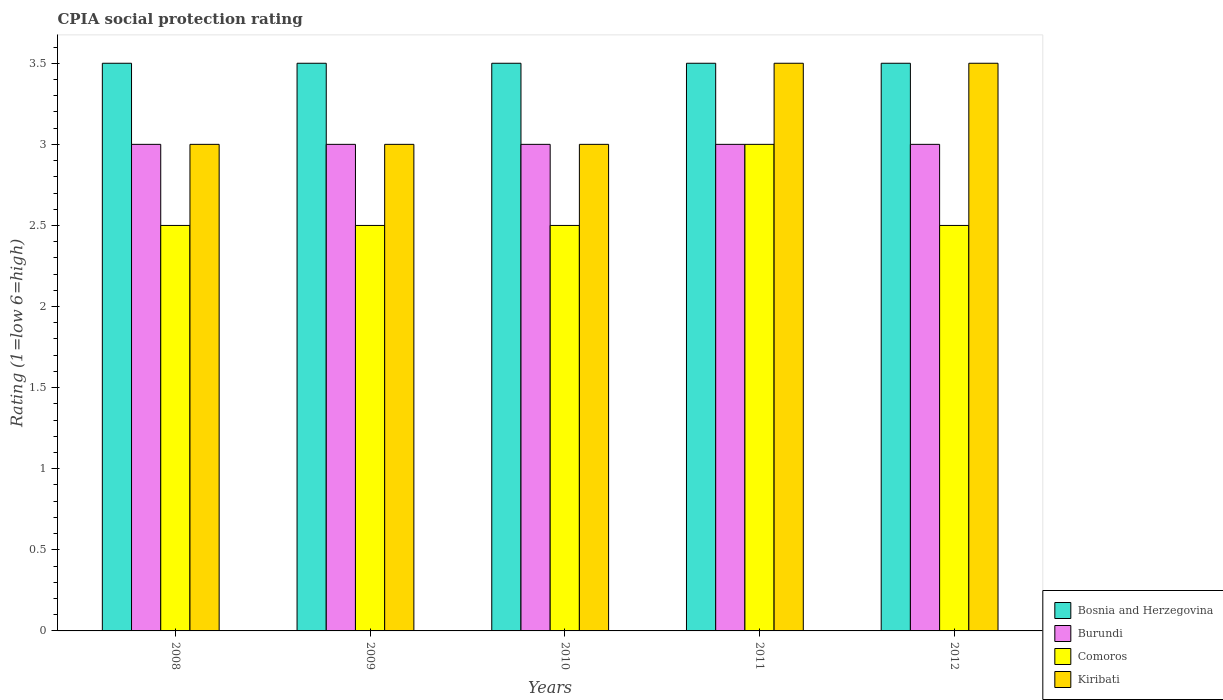How many groups of bars are there?
Ensure brevity in your answer.  5. Are the number of bars per tick equal to the number of legend labels?
Offer a terse response. Yes. How many bars are there on the 1st tick from the right?
Your answer should be compact. 4. Across all years, what is the maximum CPIA rating in Bosnia and Herzegovina?
Your answer should be compact. 3.5. Across all years, what is the minimum CPIA rating in Burundi?
Provide a succinct answer. 3. In which year was the CPIA rating in Burundi maximum?
Provide a short and direct response. 2008. What is the total CPIA rating in Burundi in the graph?
Make the answer very short. 15. What is the difference between the CPIA rating in Bosnia and Herzegovina in 2008 and that in 2010?
Provide a succinct answer. 0. What is the average CPIA rating in Bosnia and Herzegovina per year?
Offer a terse response. 3.5. What is the ratio of the CPIA rating in Comoros in 2010 to that in 2011?
Your answer should be very brief. 0.83. Is the difference between the CPIA rating in Comoros in 2010 and 2011 greater than the difference between the CPIA rating in Kiribati in 2010 and 2011?
Provide a succinct answer. No. In how many years, is the CPIA rating in Burundi greater than the average CPIA rating in Burundi taken over all years?
Ensure brevity in your answer.  0. Is the sum of the CPIA rating in Burundi in 2008 and 2009 greater than the maximum CPIA rating in Comoros across all years?
Provide a short and direct response. Yes. Is it the case that in every year, the sum of the CPIA rating in Comoros and CPIA rating in Bosnia and Herzegovina is greater than the sum of CPIA rating in Burundi and CPIA rating in Kiribati?
Offer a terse response. No. What does the 4th bar from the left in 2010 represents?
Keep it short and to the point. Kiribati. What does the 4th bar from the right in 2010 represents?
Make the answer very short. Bosnia and Herzegovina. How many years are there in the graph?
Your answer should be compact. 5. Does the graph contain any zero values?
Make the answer very short. No. Where does the legend appear in the graph?
Provide a succinct answer. Bottom right. What is the title of the graph?
Your response must be concise. CPIA social protection rating. What is the label or title of the X-axis?
Offer a terse response. Years. What is the label or title of the Y-axis?
Your answer should be very brief. Rating (1=low 6=high). What is the Rating (1=low 6=high) in Burundi in 2008?
Your response must be concise. 3. What is the Rating (1=low 6=high) of Comoros in 2008?
Your response must be concise. 2.5. What is the Rating (1=low 6=high) in Burundi in 2009?
Make the answer very short. 3. What is the Rating (1=low 6=high) of Comoros in 2009?
Your answer should be compact. 2.5. What is the Rating (1=low 6=high) in Burundi in 2010?
Give a very brief answer. 3. What is the Rating (1=low 6=high) in Comoros in 2010?
Provide a short and direct response. 2.5. What is the Rating (1=low 6=high) of Burundi in 2011?
Ensure brevity in your answer.  3. What is the Rating (1=low 6=high) of Comoros in 2011?
Your answer should be very brief. 3. What is the Rating (1=low 6=high) of Burundi in 2012?
Your answer should be compact. 3. What is the Rating (1=low 6=high) in Kiribati in 2012?
Make the answer very short. 3.5. Across all years, what is the maximum Rating (1=low 6=high) in Burundi?
Provide a short and direct response. 3. Across all years, what is the maximum Rating (1=low 6=high) of Comoros?
Provide a succinct answer. 3. Across all years, what is the maximum Rating (1=low 6=high) of Kiribati?
Provide a succinct answer. 3.5. Across all years, what is the minimum Rating (1=low 6=high) of Bosnia and Herzegovina?
Give a very brief answer. 3.5. Across all years, what is the minimum Rating (1=low 6=high) in Burundi?
Ensure brevity in your answer.  3. Across all years, what is the minimum Rating (1=low 6=high) of Kiribati?
Keep it short and to the point. 3. What is the total Rating (1=low 6=high) of Bosnia and Herzegovina in the graph?
Your answer should be compact. 17.5. What is the total Rating (1=low 6=high) of Comoros in the graph?
Make the answer very short. 13. What is the difference between the Rating (1=low 6=high) of Burundi in 2008 and that in 2009?
Make the answer very short. 0. What is the difference between the Rating (1=low 6=high) in Kiribati in 2008 and that in 2009?
Make the answer very short. 0. What is the difference between the Rating (1=low 6=high) of Kiribati in 2008 and that in 2010?
Your response must be concise. 0. What is the difference between the Rating (1=low 6=high) in Bosnia and Herzegovina in 2008 and that in 2011?
Your answer should be compact. 0. What is the difference between the Rating (1=low 6=high) of Bosnia and Herzegovina in 2008 and that in 2012?
Provide a succinct answer. 0. What is the difference between the Rating (1=low 6=high) in Burundi in 2008 and that in 2012?
Ensure brevity in your answer.  0. What is the difference between the Rating (1=low 6=high) of Comoros in 2008 and that in 2012?
Provide a short and direct response. 0. What is the difference between the Rating (1=low 6=high) of Bosnia and Herzegovina in 2009 and that in 2011?
Provide a succinct answer. 0. What is the difference between the Rating (1=low 6=high) in Comoros in 2009 and that in 2011?
Offer a very short reply. -0.5. What is the difference between the Rating (1=low 6=high) of Kiribati in 2009 and that in 2011?
Ensure brevity in your answer.  -0.5. What is the difference between the Rating (1=low 6=high) in Bosnia and Herzegovina in 2009 and that in 2012?
Your response must be concise. 0. What is the difference between the Rating (1=low 6=high) in Comoros in 2009 and that in 2012?
Offer a very short reply. 0. What is the difference between the Rating (1=low 6=high) of Bosnia and Herzegovina in 2010 and that in 2011?
Offer a very short reply. 0. What is the difference between the Rating (1=low 6=high) of Kiribati in 2010 and that in 2011?
Offer a very short reply. -0.5. What is the difference between the Rating (1=low 6=high) in Comoros in 2010 and that in 2012?
Make the answer very short. 0. What is the difference between the Rating (1=low 6=high) in Bosnia and Herzegovina in 2011 and that in 2012?
Your answer should be very brief. 0. What is the difference between the Rating (1=low 6=high) of Comoros in 2011 and that in 2012?
Provide a succinct answer. 0.5. What is the difference between the Rating (1=low 6=high) of Kiribati in 2011 and that in 2012?
Your answer should be very brief. 0. What is the difference between the Rating (1=low 6=high) in Burundi in 2008 and the Rating (1=low 6=high) in Comoros in 2009?
Ensure brevity in your answer.  0.5. What is the difference between the Rating (1=low 6=high) in Bosnia and Herzegovina in 2008 and the Rating (1=low 6=high) in Burundi in 2010?
Ensure brevity in your answer.  0.5. What is the difference between the Rating (1=low 6=high) of Bosnia and Herzegovina in 2008 and the Rating (1=low 6=high) of Comoros in 2010?
Give a very brief answer. 1. What is the difference between the Rating (1=low 6=high) of Burundi in 2008 and the Rating (1=low 6=high) of Comoros in 2010?
Offer a terse response. 0.5. What is the difference between the Rating (1=low 6=high) of Burundi in 2008 and the Rating (1=low 6=high) of Kiribati in 2010?
Offer a very short reply. 0. What is the difference between the Rating (1=low 6=high) of Bosnia and Herzegovina in 2008 and the Rating (1=low 6=high) of Burundi in 2011?
Your response must be concise. 0.5. What is the difference between the Rating (1=low 6=high) in Bosnia and Herzegovina in 2008 and the Rating (1=low 6=high) in Kiribati in 2011?
Make the answer very short. 0. What is the difference between the Rating (1=low 6=high) in Burundi in 2008 and the Rating (1=low 6=high) in Comoros in 2011?
Your answer should be very brief. 0. What is the difference between the Rating (1=low 6=high) of Burundi in 2008 and the Rating (1=low 6=high) of Kiribati in 2011?
Your answer should be very brief. -0.5. What is the difference between the Rating (1=low 6=high) of Bosnia and Herzegovina in 2008 and the Rating (1=low 6=high) of Burundi in 2012?
Your answer should be compact. 0.5. What is the difference between the Rating (1=low 6=high) in Bosnia and Herzegovina in 2008 and the Rating (1=low 6=high) in Comoros in 2012?
Offer a terse response. 1. What is the difference between the Rating (1=low 6=high) in Bosnia and Herzegovina in 2008 and the Rating (1=low 6=high) in Kiribati in 2012?
Your response must be concise. 0. What is the difference between the Rating (1=low 6=high) of Burundi in 2008 and the Rating (1=low 6=high) of Comoros in 2012?
Your response must be concise. 0.5. What is the difference between the Rating (1=low 6=high) in Burundi in 2008 and the Rating (1=low 6=high) in Kiribati in 2012?
Your answer should be very brief. -0.5. What is the difference between the Rating (1=low 6=high) of Bosnia and Herzegovina in 2009 and the Rating (1=low 6=high) of Burundi in 2010?
Make the answer very short. 0.5. What is the difference between the Rating (1=low 6=high) of Bosnia and Herzegovina in 2009 and the Rating (1=low 6=high) of Comoros in 2010?
Offer a terse response. 1. What is the difference between the Rating (1=low 6=high) of Bosnia and Herzegovina in 2009 and the Rating (1=low 6=high) of Kiribati in 2010?
Make the answer very short. 0.5. What is the difference between the Rating (1=low 6=high) in Burundi in 2009 and the Rating (1=low 6=high) in Comoros in 2010?
Make the answer very short. 0.5. What is the difference between the Rating (1=low 6=high) in Burundi in 2009 and the Rating (1=low 6=high) in Kiribati in 2010?
Your answer should be very brief. 0. What is the difference between the Rating (1=low 6=high) of Bosnia and Herzegovina in 2009 and the Rating (1=low 6=high) of Comoros in 2011?
Keep it short and to the point. 0.5. What is the difference between the Rating (1=low 6=high) of Burundi in 2009 and the Rating (1=low 6=high) of Comoros in 2011?
Provide a short and direct response. 0. What is the difference between the Rating (1=low 6=high) of Comoros in 2009 and the Rating (1=low 6=high) of Kiribati in 2011?
Your answer should be compact. -1. What is the difference between the Rating (1=low 6=high) in Bosnia and Herzegovina in 2009 and the Rating (1=low 6=high) in Burundi in 2012?
Provide a short and direct response. 0.5. What is the difference between the Rating (1=low 6=high) of Bosnia and Herzegovina in 2009 and the Rating (1=low 6=high) of Comoros in 2012?
Make the answer very short. 1. What is the difference between the Rating (1=low 6=high) in Bosnia and Herzegovina in 2009 and the Rating (1=low 6=high) in Kiribati in 2012?
Your response must be concise. 0. What is the difference between the Rating (1=low 6=high) of Comoros in 2009 and the Rating (1=low 6=high) of Kiribati in 2012?
Provide a succinct answer. -1. What is the difference between the Rating (1=low 6=high) of Bosnia and Herzegovina in 2010 and the Rating (1=low 6=high) of Comoros in 2011?
Your response must be concise. 0.5. What is the difference between the Rating (1=low 6=high) in Bosnia and Herzegovina in 2010 and the Rating (1=low 6=high) in Kiribati in 2011?
Make the answer very short. 0. What is the difference between the Rating (1=low 6=high) in Bosnia and Herzegovina in 2010 and the Rating (1=low 6=high) in Comoros in 2012?
Your answer should be very brief. 1. What is the difference between the Rating (1=low 6=high) of Bosnia and Herzegovina in 2010 and the Rating (1=low 6=high) of Kiribati in 2012?
Give a very brief answer. 0. What is the difference between the Rating (1=low 6=high) of Burundi in 2010 and the Rating (1=low 6=high) of Comoros in 2012?
Your answer should be very brief. 0.5. What is the difference between the Rating (1=low 6=high) in Bosnia and Herzegovina in 2011 and the Rating (1=low 6=high) in Comoros in 2012?
Ensure brevity in your answer.  1. What is the difference between the Rating (1=low 6=high) of Bosnia and Herzegovina in 2011 and the Rating (1=low 6=high) of Kiribati in 2012?
Offer a terse response. 0. What is the difference between the Rating (1=low 6=high) in Comoros in 2011 and the Rating (1=low 6=high) in Kiribati in 2012?
Make the answer very short. -0.5. What is the average Rating (1=low 6=high) in Kiribati per year?
Give a very brief answer. 3.2. In the year 2008, what is the difference between the Rating (1=low 6=high) in Bosnia and Herzegovina and Rating (1=low 6=high) in Burundi?
Your answer should be compact. 0.5. In the year 2008, what is the difference between the Rating (1=low 6=high) in Bosnia and Herzegovina and Rating (1=low 6=high) in Comoros?
Give a very brief answer. 1. In the year 2008, what is the difference between the Rating (1=low 6=high) in Burundi and Rating (1=low 6=high) in Kiribati?
Offer a very short reply. 0. In the year 2008, what is the difference between the Rating (1=low 6=high) in Comoros and Rating (1=low 6=high) in Kiribati?
Offer a terse response. -0.5. In the year 2009, what is the difference between the Rating (1=low 6=high) of Bosnia and Herzegovina and Rating (1=low 6=high) of Burundi?
Your answer should be very brief. 0.5. In the year 2009, what is the difference between the Rating (1=low 6=high) in Bosnia and Herzegovina and Rating (1=low 6=high) in Comoros?
Ensure brevity in your answer.  1. In the year 2009, what is the difference between the Rating (1=low 6=high) in Bosnia and Herzegovina and Rating (1=low 6=high) in Kiribati?
Provide a short and direct response. 0.5. In the year 2009, what is the difference between the Rating (1=low 6=high) in Comoros and Rating (1=low 6=high) in Kiribati?
Your answer should be compact. -0.5. In the year 2010, what is the difference between the Rating (1=low 6=high) in Bosnia and Herzegovina and Rating (1=low 6=high) in Burundi?
Offer a very short reply. 0.5. In the year 2010, what is the difference between the Rating (1=low 6=high) in Burundi and Rating (1=low 6=high) in Kiribati?
Provide a short and direct response. 0. In the year 2010, what is the difference between the Rating (1=low 6=high) in Comoros and Rating (1=low 6=high) in Kiribati?
Offer a very short reply. -0.5. In the year 2011, what is the difference between the Rating (1=low 6=high) of Bosnia and Herzegovina and Rating (1=low 6=high) of Burundi?
Your answer should be very brief. 0.5. In the year 2011, what is the difference between the Rating (1=low 6=high) in Bosnia and Herzegovina and Rating (1=low 6=high) in Kiribati?
Provide a short and direct response. 0. In the year 2011, what is the difference between the Rating (1=low 6=high) of Burundi and Rating (1=low 6=high) of Kiribati?
Your answer should be compact. -0.5. In the year 2012, what is the difference between the Rating (1=low 6=high) of Bosnia and Herzegovina and Rating (1=low 6=high) of Burundi?
Your answer should be compact. 0.5. In the year 2012, what is the difference between the Rating (1=low 6=high) in Bosnia and Herzegovina and Rating (1=low 6=high) in Kiribati?
Provide a succinct answer. 0. In the year 2012, what is the difference between the Rating (1=low 6=high) of Burundi and Rating (1=low 6=high) of Comoros?
Offer a terse response. 0.5. In the year 2012, what is the difference between the Rating (1=low 6=high) in Burundi and Rating (1=low 6=high) in Kiribati?
Keep it short and to the point. -0.5. In the year 2012, what is the difference between the Rating (1=low 6=high) of Comoros and Rating (1=low 6=high) of Kiribati?
Your answer should be very brief. -1. What is the ratio of the Rating (1=low 6=high) in Burundi in 2008 to that in 2009?
Ensure brevity in your answer.  1. What is the ratio of the Rating (1=low 6=high) of Comoros in 2008 to that in 2009?
Provide a short and direct response. 1. What is the ratio of the Rating (1=low 6=high) of Kiribati in 2008 to that in 2009?
Your answer should be compact. 1. What is the ratio of the Rating (1=low 6=high) in Bosnia and Herzegovina in 2008 to that in 2010?
Offer a very short reply. 1. What is the ratio of the Rating (1=low 6=high) in Burundi in 2008 to that in 2010?
Your response must be concise. 1. What is the ratio of the Rating (1=low 6=high) of Comoros in 2008 to that in 2010?
Your answer should be very brief. 1. What is the ratio of the Rating (1=low 6=high) in Bosnia and Herzegovina in 2008 to that in 2011?
Give a very brief answer. 1. What is the ratio of the Rating (1=low 6=high) in Comoros in 2008 to that in 2011?
Your answer should be compact. 0.83. What is the ratio of the Rating (1=low 6=high) in Kiribati in 2008 to that in 2011?
Offer a terse response. 0.86. What is the ratio of the Rating (1=low 6=high) in Comoros in 2008 to that in 2012?
Provide a succinct answer. 1. What is the ratio of the Rating (1=low 6=high) in Kiribati in 2008 to that in 2012?
Keep it short and to the point. 0.86. What is the ratio of the Rating (1=low 6=high) of Burundi in 2009 to that in 2010?
Your response must be concise. 1. What is the ratio of the Rating (1=low 6=high) in Bosnia and Herzegovina in 2009 to that in 2011?
Your answer should be very brief. 1. What is the ratio of the Rating (1=low 6=high) in Comoros in 2009 to that in 2011?
Make the answer very short. 0.83. What is the ratio of the Rating (1=low 6=high) of Kiribati in 2009 to that in 2012?
Ensure brevity in your answer.  0.86. What is the ratio of the Rating (1=low 6=high) in Bosnia and Herzegovina in 2010 to that in 2011?
Provide a short and direct response. 1. What is the ratio of the Rating (1=low 6=high) of Burundi in 2010 to that in 2011?
Keep it short and to the point. 1. What is the ratio of the Rating (1=low 6=high) in Kiribati in 2010 to that in 2011?
Offer a very short reply. 0.86. What is the ratio of the Rating (1=low 6=high) of Bosnia and Herzegovina in 2010 to that in 2012?
Offer a terse response. 1. What is the ratio of the Rating (1=low 6=high) of Burundi in 2010 to that in 2012?
Offer a terse response. 1. What is the ratio of the Rating (1=low 6=high) of Comoros in 2010 to that in 2012?
Offer a very short reply. 1. What is the ratio of the Rating (1=low 6=high) in Kiribati in 2010 to that in 2012?
Provide a short and direct response. 0.86. What is the ratio of the Rating (1=low 6=high) of Bosnia and Herzegovina in 2011 to that in 2012?
Your answer should be compact. 1. What is the ratio of the Rating (1=low 6=high) in Burundi in 2011 to that in 2012?
Your response must be concise. 1. What is the ratio of the Rating (1=low 6=high) of Comoros in 2011 to that in 2012?
Keep it short and to the point. 1.2. What is the ratio of the Rating (1=low 6=high) of Kiribati in 2011 to that in 2012?
Offer a very short reply. 1. What is the difference between the highest and the second highest Rating (1=low 6=high) in Bosnia and Herzegovina?
Offer a very short reply. 0. What is the difference between the highest and the second highest Rating (1=low 6=high) of Kiribati?
Your answer should be compact. 0. What is the difference between the highest and the lowest Rating (1=low 6=high) of Bosnia and Herzegovina?
Offer a very short reply. 0. What is the difference between the highest and the lowest Rating (1=low 6=high) of Burundi?
Make the answer very short. 0. What is the difference between the highest and the lowest Rating (1=low 6=high) in Comoros?
Offer a very short reply. 0.5. 